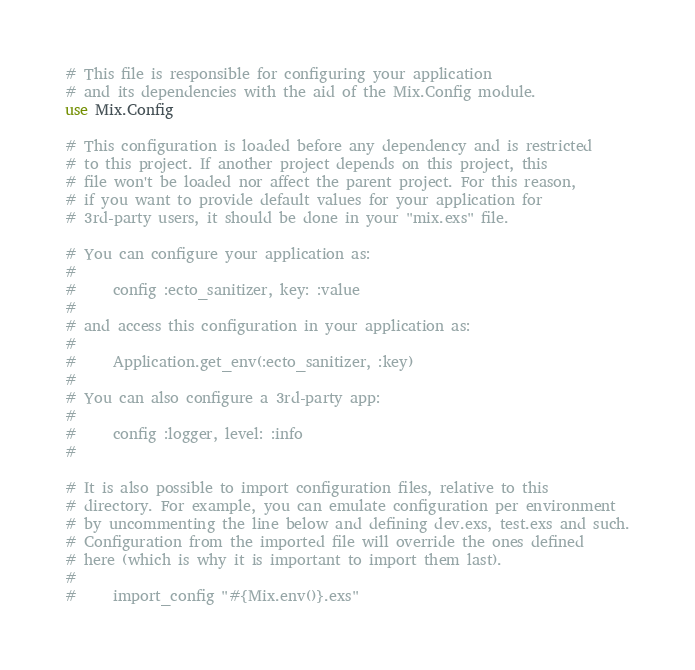Convert code to text. <code><loc_0><loc_0><loc_500><loc_500><_Elixir_># This file is responsible for configuring your application
# and its dependencies with the aid of the Mix.Config module.
use Mix.Config

# This configuration is loaded before any dependency and is restricted
# to this project. If another project depends on this project, this
# file won't be loaded nor affect the parent project. For this reason,
# if you want to provide default values for your application for
# 3rd-party users, it should be done in your "mix.exs" file.

# You can configure your application as:
#
#     config :ecto_sanitizer, key: :value
#
# and access this configuration in your application as:
#
#     Application.get_env(:ecto_sanitizer, :key)
#
# You can also configure a 3rd-party app:
#
#     config :logger, level: :info
#

# It is also possible to import configuration files, relative to this
# directory. For example, you can emulate configuration per environment
# by uncommenting the line below and defining dev.exs, test.exs and such.
# Configuration from the imported file will override the ones defined
# here (which is why it is important to import them last).
#
#     import_config "#{Mix.env()}.exs"
</code> 